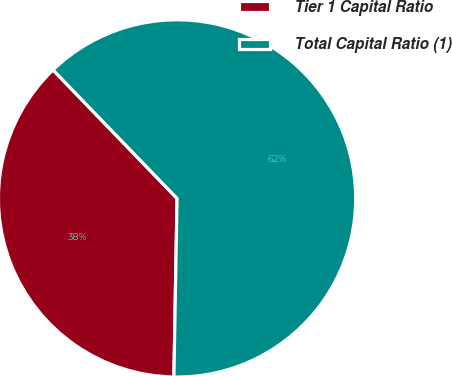<chart> <loc_0><loc_0><loc_500><loc_500><pie_chart><fcel>Tier 1 Capital Ratio<fcel>Total Capital Ratio (1)<nl><fcel>37.5%<fcel>62.5%<nl></chart> 